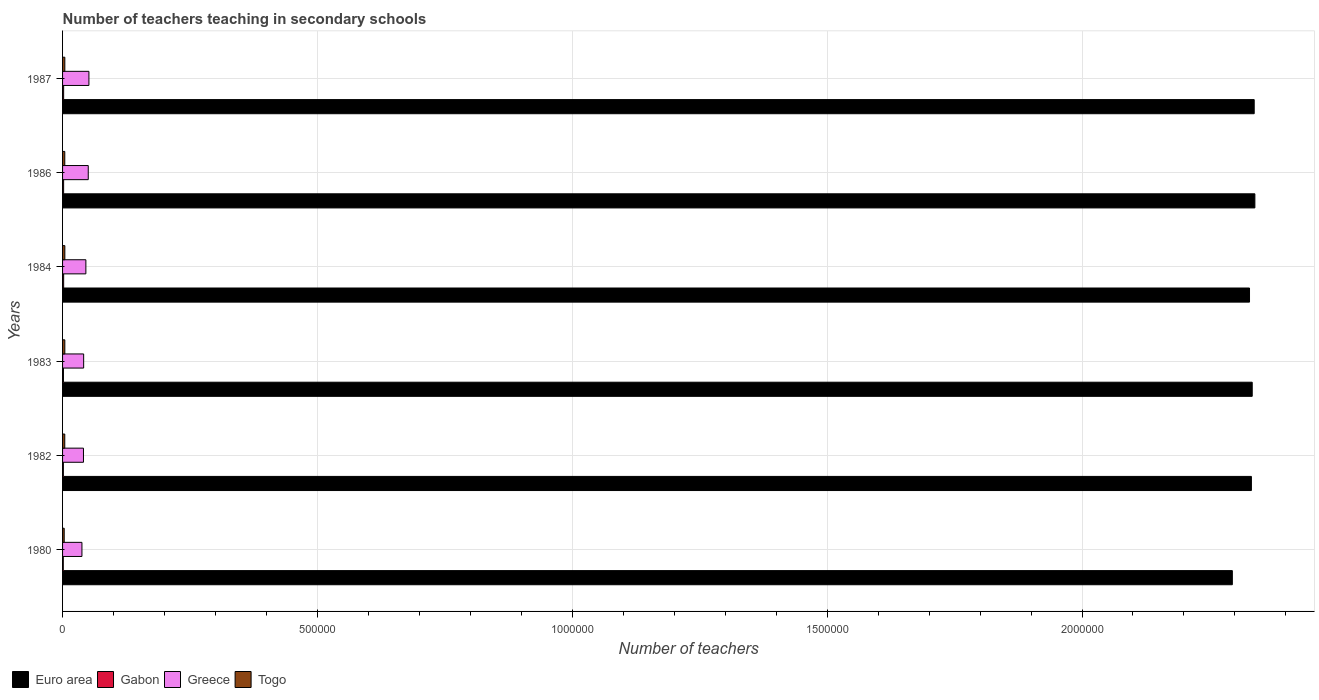How many bars are there on the 1st tick from the top?
Offer a very short reply. 4. In how many cases, is the number of bars for a given year not equal to the number of legend labels?
Your answer should be very brief. 0. What is the number of teachers teaching in secondary schools in Gabon in 1980?
Make the answer very short. 1437. Across all years, what is the maximum number of teachers teaching in secondary schools in Togo?
Offer a terse response. 4481. Across all years, what is the minimum number of teachers teaching in secondary schools in Greece?
Provide a succinct answer. 3.80e+04. In which year was the number of teachers teaching in secondary schools in Togo maximum?
Offer a terse response. 1984. What is the total number of teachers teaching in secondary schools in Gabon in the graph?
Give a very brief answer. 1.11e+04. What is the difference between the number of teachers teaching in secondary schools in Gabon in 1980 and that in 1984?
Offer a very short reply. -698. What is the difference between the number of teachers teaching in secondary schools in Euro area in 1987 and the number of teachers teaching in secondary schools in Greece in 1986?
Your response must be concise. 2.29e+06. What is the average number of teachers teaching in secondary schools in Greece per year?
Your response must be concise. 4.47e+04. In the year 1986, what is the difference between the number of teachers teaching in secondary schools in Gabon and number of teachers teaching in secondary schools in Euro area?
Keep it short and to the point. -2.34e+06. In how many years, is the number of teachers teaching in secondary schools in Gabon greater than 100000 ?
Offer a terse response. 0. What is the ratio of the number of teachers teaching in secondary schools in Gabon in 1982 to that in 1983?
Give a very brief answer. 0.91. Is the number of teachers teaching in secondary schools in Euro area in 1983 less than that in 1986?
Ensure brevity in your answer.  Yes. What is the difference between the highest and the second highest number of teachers teaching in secondary schools in Togo?
Your response must be concise. 43. What is the difference between the highest and the lowest number of teachers teaching in secondary schools in Togo?
Provide a succinct answer. 1264. What does the 1st bar from the top in 1986 represents?
Keep it short and to the point. Togo. How many years are there in the graph?
Ensure brevity in your answer.  6. Are the values on the major ticks of X-axis written in scientific E-notation?
Keep it short and to the point. No. Does the graph contain any zero values?
Provide a short and direct response. No. Where does the legend appear in the graph?
Provide a succinct answer. Bottom left. How many legend labels are there?
Your response must be concise. 4. How are the legend labels stacked?
Your answer should be very brief. Horizontal. What is the title of the graph?
Your answer should be compact. Number of teachers teaching in secondary schools. What is the label or title of the X-axis?
Offer a terse response. Number of teachers. What is the label or title of the Y-axis?
Make the answer very short. Years. What is the Number of teachers in Euro area in 1980?
Your answer should be very brief. 2.29e+06. What is the Number of teachers of Gabon in 1980?
Offer a terse response. 1437. What is the Number of teachers in Greece in 1980?
Your answer should be very brief. 3.80e+04. What is the Number of teachers of Togo in 1980?
Make the answer very short. 3217. What is the Number of teachers of Euro area in 1982?
Keep it short and to the point. 2.33e+06. What is the Number of teachers in Gabon in 1982?
Provide a short and direct response. 1583. What is the Number of teachers of Greece in 1982?
Ensure brevity in your answer.  4.10e+04. What is the Number of teachers in Togo in 1982?
Your response must be concise. 4319. What is the Number of teachers in Euro area in 1983?
Your response must be concise. 2.33e+06. What is the Number of teachers in Gabon in 1983?
Make the answer very short. 1743. What is the Number of teachers in Greece in 1983?
Make the answer very short. 4.14e+04. What is the Number of teachers of Togo in 1983?
Your answer should be compact. 4438. What is the Number of teachers of Euro area in 1984?
Provide a short and direct response. 2.33e+06. What is the Number of teachers in Gabon in 1984?
Keep it short and to the point. 2135. What is the Number of teachers of Greece in 1984?
Make the answer very short. 4.57e+04. What is the Number of teachers in Togo in 1984?
Provide a short and direct response. 4481. What is the Number of teachers in Euro area in 1986?
Make the answer very short. 2.34e+06. What is the Number of teachers in Gabon in 1986?
Ensure brevity in your answer.  2074. What is the Number of teachers in Greece in 1986?
Keep it short and to the point. 5.04e+04. What is the Number of teachers in Togo in 1986?
Your answer should be compact. 4351. What is the Number of teachers of Euro area in 1987?
Ensure brevity in your answer.  2.34e+06. What is the Number of teachers in Gabon in 1987?
Your answer should be very brief. 2120. What is the Number of teachers of Greece in 1987?
Ensure brevity in your answer.  5.17e+04. What is the Number of teachers of Togo in 1987?
Offer a very short reply. 4424. Across all years, what is the maximum Number of teachers of Euro area?
Provide a short and direct response. 2.34e+06. Across all years, what is the maximum Number of teachers of Gabon?
Keep it short and to the point. 2135. Across all years, what is the maximum Number of teachers in Greece?
Keep it short and to the point. 5.17e+04. Across all years, what is the maximum Number of teachers in Togo?
Keep it short and to the point. 4481. Across all years, what is the minimum Number of teachers of Euro area?
Ensure brevity in your answer.  2.29e+06. Across all years, what is the minimum Number of teachers of Gabon?
Make the answer very short. 1437. Across all years, what is the minimum Number of teachers in Greece?
Give a very brief answer. 3.80e+04. Across all years, what is the minimum Number of teachers of Togo?
Offer a terse response. 3217. What is the total Number of teachers in Euro area in the graph?
Offer a very short reply. 1.40e+07. What is the total Number of teachers of Gabon in the graph?
Your response must be concise. 1.11e+04. What is the total Number of teachers in Greece in the graph?
Your answer should be very brief. 2.68e+05. What is the total Number of teachers of Togo in the graph?
Your answer should be very brief. 2.52e+04. What is the difference between the Number of teachers in Euro area in 1980 and that in 1982?
Ensure brevity in your answer.  -3.74e+04. What is the difference between the Number of teachers of Gabon in 1980 and that in 1982?
Your answer should be compact. -146. What is the difference between the Number of teachers of Greece in 1980 and that in 1982?
Give a very brief answer. -3024. What is the difference between the Number of teachers in Togo in 1980 and that in 1982?
Provide a succinct answer. -1102. What is the difference between the Number of teachers in Euro area in 1980 and that in 1983?
Keep it short and to the point. -3.90e+04. What is the difference between the Number of teachers of Gabon in 1980 and that in 1983?
Your answer should be compact. -306. What is the difference between the Number of teachers of Greece in 1980 and that in 1983?
Offer a terse response. -3368. What is the difference between the Number of teachers in Togo in 1980 and that in 1983?
Your answer should be compact. -1221. What is the difference between the Number of teachers of Euro area in 1980 and that in 1984?
Provide a short and direct response. -3.37e+04. What is the difference between the Number of teachers of Gabon in 1980 and that in 1984?
Make the answer very short. -698. What is the difference between the Number of teachers in Greece in 1980 and that in 1984?
Provide a short and direct response. -7715. What is the difference between the Number of teachers in Togo in 1980 and that in 1984?
Provide a succinct answer. -1264. What is the difference between the Number of teachers in Euro area in 1980 and that in 1986?
Provide a short and direct response. -4.42e+04. What is the difference between the Number of teachers of Gabon in 1980 and that in 1986?
Give a very brief answer. -637. What is the difference between the Number of teachers in Greece in 1980 and that in 1986?
Your answer should be compact. -1.24e+04. What is the difference between the Number of teachers in Togo in 1980 and that in 1986?
Offer a terse response. -1134. What is the difference between the Number of teachers of Euro area in 1980 and that in 1987?
Offer a very short reply. -4.29e+04. What is the difference between the Number of teachers in Gabon in 1980 and that in 1987?
Provide a succinct answer. -683. What is the difference between the Number of teachers of Greece in 1980 and that in 1987?
Make the answer very short. -1.37e+04. What is the difference between the Number of teachers in Togo in 1980 and that in 1987?
Your answer should be compact. -1207. What is the difference between the Number of teachers in Euro area in 1982 and that in 1983?
Provide a short and direct response. -1573.5. What is the difference between the Number of teachers of Gabon in 1982 and that in 1983?
Ensure brevity in your answer.  -160. What is the difference between the Number of teachers of Greece in 1982 and that in 1983?
Your response must be concise. -344. What is the difference between the Number of teachers of Togo in 1982 and that in 1983?
Your answer should be compact. -119. What is the difference between the Number of teachers of Euro area in 1982 and that in 1984?
Offer a very short reply. 3733. What is the difference between the Number of teachers of Gabon in 1982 and that in 1984?
Provide a succinct answer. -552. What is the difference between the Number of teachers in Greece in 1982 and that in 1984?
Keep it short and to the point. -4691. What is the difference between the Number of teachers in Togo in 1982 and that in 1984?
Your response must be concise. -162. What is the difference between the Number of teachers in Euro area in 1982 and that in 1986?
Provide a succinct answer. -6799.75. What is the difference between the Number of teachers in Gabon in 1982 and that in 1986?
Provide a succinct answer. -491. What is the difference between the Number of teachers of Greece in 1982 and that in 1986?
Provide a succinct answer. -9365. What is the difference between the Number of teachers of Togo in 1982 and that in 1986?
Your answer should be very brief. -32. What is the difference between the Number of teachers of Euro area in 1982 and that in 1987?
Your answer should be very brief. -5475.5. What is the difference between the Number of teachers of Gabon in 1982 and that in 1987?
Your response must be concise. -537. What is the difference between the Number of teachers in Greece in 1982 and that in 1987?
Your answer should be very brief. -1.07e+04. What is the difference between the Number of teachers of Togo in 1982 and that in 1987?
Offer a very short reply. -105. What is the difference between the Number of teachers in Euro area in 1983 and that in 1984?
Provide a succinct answer. 5306.5. What is the difference between the Number of teachers in Gabon in 1983 and that in 1984?
Provide a succinct answer. -392. What is the difference between the Number of teachers in Greece in 1983 and that in 1984?
Make the answer very short. -4347. What is the difference between the Number of teachers of Togo in 1983 and that in 1984?
Your answer should be very brief. -43. What is the difference between the Number of teachers in Euro area in 1983 and that in 1986?
Give a very brief answer. -5226.25. What is the difference between the Number of teachers in Gabon in 1983 and that in 1986?
Ensure brevity in your answer.  -331. What is the difference between the Number of teachers of Greece in 1983 and that in 1986?
Offer a very short reply. -9021. What is the difference between the Number of teachers of Togo in 1983 and that in 1986?
Provide a short and direct response. 87. What is the difference between the Number of teachers in Euro area in 1983 and that in 1987?
Your answer should be compact. -3902. What is the difference between the Number of teachers of Gabon in 1983 and that in 1987?
Your answer should be compact. -377. What is the difference between the Number of teachers in Greece in 1983 and that in 1987?
Offer a very short reply. -1.03e+04. What is the difference between the Number of teachers in Euro area in 1984 and that in 1986?
Keep it short and to the point. -1.05e+04. What is the difference between the Number of teachers in Greece in 1984 and that in 1986?
Offer a very short reply. -4674. What is the difference between the Number of teachers in Togo in 1984 and that in 1986?
Give a very brief answer. 130. What is the difference between the Number of teachers of Euro area in 1984 and that in 1987?
Ensure brevity in your answer.  -9208.5. What is the difference between the Number of teachers in Gabon in 1984 and that in 1987?
Your response must be concise. 15. What is the difference between the Number of teachers of Greece in 1984 and that in 1987?
Your answer should be very brief. -5992. What is the difference between the Number of teachers of Euro area in 1986 and that in 1987?
Keep it short and to the point. 1324.25. What is the difference between the Number of teachers of Gabon in 1986 and that in 1987?
Offer a terse response. -46. What is the difference between the Number of teachers of Greece in 1986 and that in 1987?
Ensure brevity in your answer.  -1318. What is the difference between the Number of teachers of Togo in 1986 and that in 1987?
Give a very brief answer. -73. What is the difference between the Number of teachers of Euro area in 1980 and the Number of teachers of Gabon in 1982?
Give a very brief answer. 2.29e+06. What is the difference between the Number of teachers in Euro area in 1980 and the Number of teachers in Greece in 1982?
Keep it short and to the point. 2.25e+06. What is the difference between the Number of teachers of Euro area in 1980 and the Number of teachers of Togo in 1982?
Your answer should be very brief. 2.29e+06. What is the difference between the Number of teachers in Gabon in 1980 and the Number of teachers in Greece in 1982?
Your answer should be very brief. -3.96e+04. What is the difference between the Number of teachers in Gabon in 1980 and the Number of teachers in Togo in 1982?
Your response must be concise. -2882. What is the difference between the Number of teachers of Greece in 1980 and the Number of teachers of Togo in 1982?
Offer a terse response. 3.37e+04. What is the difference between the Number of teachers of Euro area in 1980 and the Number of teachers of Gabon in 1983?
Give a very brief answer. 2.29e+06. What is the difference between the Number of teachers in Euro area in 1980 and the Number of teachers in Greece in 1983?
Your answer should be compact. 2.25e+06. What is the difference between the Number of teachers in Euro area in 1980 and the Number of teachers in Togo in 1983?
Make the answer very short. 2.29e+06. What is the difference between the Number of teachers in Gabon in 1980 and the Number of teachers in Greece in 1983?
Your response must be concise. -3.99e+04. What is the difference between the Number of teachers in Gabon in 1980 and the Number of teachers in Togo in 1983?
Provide a short and direct response. -3001. What is the difference between the Number of teachers in Greece in 1980 and the Number of teachers in Togo in 1983?
Give a very brief answer. 3.36e+04. What is the difference between the Number of teachers of Euro area in 1980 and the Number of teachers of Gabon in 1984?
Provide a succinct answer. 2.29e+06. What is the difference between the Number of teachers of Euro area in 1980 and the Number of teachers of Greece in 1984?
Offer a terse response. 2.25e+06. What is the difference between the Number of teachers of Euro area in 1980 and the Number of teachers of Togo in 1984?
Make the answer very short. 2.29e+06. What is the difference between the Number of teachers in Gabon in 1980 and the Number of teachers in Greece in 1984?
Your response must be concise. -4.43e+04. What is the difference between the Number of teachers of Gabon in 1980 and the Number of teachers of Togo in 1984?
Keep it short and to the point. -3044. What is the difference between the Number of teachers in Greece in 1980 and the Number of teachers in Togo in 1984?
Make the answer very short. 3.35e+04. What is the difference between the Number of teachers in Euro area in 1980 and the Number of teachers in Gabon in 1986?
Keep it short and to the point. 2.29e+06. What is the difference between the Number of teachers in Euro area in 1980 and the Number of teachers in Greece in 1986?
Your answer should be very brief. 2.24e+06. What is the difference between the Number of teachers in Euro area in 1980 and the Number of teachers in Togo in 1986?
Offer a very short reply. 2.29e+06. What is the difference between the Number of teachers in Gabon in 1980 and the Number of teachers in Greece in 1986?
Make the answer very short. -4.90e+04. What is the difference between the Number of teachers in Gabon in 1980 and the Number of teachers in Togo in 1986?
Your answer should be very brief. -2914. What is the difference between the Number of teachers of Greece in 1980 and the Number of teachers of Togo in 1986?
Keep it short and to the point. 3.36e+04. What is the difference between the Number of teachers of Euro area in 1980 and the Number of teachers of Gabon in 1987?
Your answer should be very brief. 2.29e+06. What is the difference between the Number of teachers of Euro area in 1980 and the Number of teachers of Greece in 1987?
Ensure brevity in your answer.  2.24e+06. What is the difference between the Number of teachers of Euro area in 1980 and the Number of teachers of Togo in 1987?
Provide a short and direct response. 2.29e+06. What is the difference between the Number of teachers of Gabon in 1980 and the Number of teachers of Greece in 1987?
Provide a succinct answer. -5.03e+04. What is the difference between the Number of teachers in Gabon in 1980 and the Number of teachers in Togo in 1987?
Your answer should be very brief. -2987. What is the difference between the Number of teachers in Greece in 1980 and the Number of teachers in Togo in 1987?
Offer a terse response. 3.36e+04. What is the difference between the Number of teachers in Euro area in 1982 and the Number of teachers in Gabon in 1983?
Give a very brief answer. 2.33e+06. What is the difference between the Number of teachers of Euro area in 1982 and the Number of teachers of Greece in 1983?
Give a very brief answer. 2.29e+06. What is the difference between the Number of teachers in Euro area in 1982 and the Number of teachers in Togo in 1983?
Your response must be concise. 2.33e+06. What is the difference between the Number of teachers in Gabon in 1982 and the Number of teachers in Greece in 1983?
Ensure brevity in your answer.  -3.98e+04. What is the difference between the Number of teachers in Gabon in 1982 and the Number of teachers in Togo in 1983?
Give a very brief answer. -2855. What is the difference between the Number of teachers in Greece in 1982 and the Number of teachers in Togo in 1983?
Ensure brevity in your answer.  3.66e+04. What is the difference between the Number of teachers in Euro area in 1982 and the Number of teachers in Gabon in 1984?
Give a very brief answer. 2.33e+06. What is the difference between the Number of teachers in Euro area in 1982 and the Number of teachers in Greece in 1984?
Offer a very short reply. 2.29e+06. What is the difference between the Number of teachers in Euro area in 1982 and the Number of teachers in Togo in 1984?
Offer a very short reply. 2.33e+06. What is the difference between the Number of teachers in Gabon in 1982 and the Number of teachers in Greece in 1984?
Your answer should be very brief. -4.41e+04. What is the difference between the Number of teachers of Gabon in 1982 and the Number of teachers of Togo in 1984?
Provide a short and direct response. -2898. What is the difference between the Number of teachers of Greece in 1982 and the Number of teachers of Togo in 1984?
Your answer should be very brief. 3.65e+04. What is the difference between the Number of teachers in Euro area in 1982 and the Number of teachers in Gabon in 1986?
Your answer should be compact. 2.33e+06. What is the difference between the Number of teachers of Euro area in 1982 and the Number of teachers of Greece in 1986?
Provide a short and direct response. 2.28e+06. What is the difference between the Number of teachers of Euro area in 1982 and the Number of teachers of Togo in 1986?
Keep it short and to the point. 2.33e+06. What is the difference between the Number of teachers in Gabon in 1982 and the Number of teachers in Greece in 1986?
Ensure brevity in your answer.  -4.88e+04. What is the difference between the Number of teachers in Gabon in 1982 and the Number of teachers in Togo in 1986?
Keep it short and to the point. -2768. What is the difference between the Number of teachers in Greece in 1982 and the Number of teachers in Togo in 1986?
Offer a very short reply. 3.67e+04. What is the difference between the Number of teachers of Euro area in 1982 and the Number of teachers of Gabon in 1987?
Provide a short and direct response. 2.33e+06. What is the difference between the Number of teachers of Euro area in 1982 and the Number of teachers of Greece in 1987?
Your answer should be very brief. 2.28e+06. What is the difference between the Number of teachers in Euro area in 1982 and the Number of teachers in Togo in 1987?
Offer a very short reply. 2.33e+06. What is the difference between the Number of teachers in Gabon in 1982 and the Number of teachers in Greece in 1987?
Give a very brief answer. -5.01e+04. What is the difference between the Number of teachers in Gabon in 1982 and the Number of teachers in Togo in 1987?
Keep it short and to the point. -2841. What is the difference between the Number of teachers of Greece in 1982 and the Number of teachers of Togo in 1987?
Ensure brevity in your answer.  3.66e+04. What is the difference between the Number of teachers of Euro area in 1983 and the Number of teachers of Gabon in 1984?
Your answer should be compact. 2.33e+06. What is the difference between the Number of teachers in Euro area in 1983 and the Number of teachers in Greece in 1984?
Keep it short and to the point. 2.29e+06. What is the difference between the Number of teachers in Euro area in 1983 and the Number of teachers in Togo in 1984?
Provide a succinct answer. 2.33e+06. What is the difference between the Number of teachers in Gabon in 1983 and the Number of teachers in Greece in 1984?
Offer a terse response. -4.40e+04. What is the difference between the Number of teachers in Gabon in 1983 and the Number of teachers in Togo in 1984?
Your answer should be compact. -2738. What is the difference between the Number of teachers in Greece in 1983 and the Number of teachers in Togo in 1984?
Offer a very short reply. 3.69e+04. What is the difference between the Number of teachers of Euro area in 1983 and the Number of teachers of Gabon in 1986?
Keep it short and to the point. 2.33e+06. What is the difference between the Number of teachers of Euro area in 1983 and the Number of teachers of Greece in 1986?
Make the answer very short. 2.28e+06. What is the difference between the Number of teachers in Euro area in 1983 and the Number of teachers in Togo in 1986?
Keep it short and to the point. 2.33e+06. What is the difference between the Number of teachers of Gabon in 1983 and the Number of teachers of Greece in 1986?
Your answer should be compact. -4.86e+04. What is the difference between the Number of teachers in Gabon in 1983 and the Number of teachers in Togo in 1986?
Make the answer very short. -2608. What is the difference between the Number of teachers of Greece in 1983 and the Number of teachers of Togo in 1986?
Your answer should be very brief. 3.70e+04. What is the difference between the Number of teachers of Euro area in 1983 and the Number of teachers of Gabon in 1987?
Your answer should be compact. 2.33e+06. What is the difference between the Number of teachers of Euro area in 1983 and the Number of teachers of Greece in 1987?
Give a very brief answer. 2.28e+06. What is the difference between the Number of teachers in Euro area in 1983 and the Number of teachers in Togo in 1987?
Give a very brief answer. 2.33e+06. What is the difference between the Number of teachers in Gabon in 1983 and the Number of teachers in Greece in 1987?
Provide a short and direct response. -5.00e+04. What is the difference between the Number of teachers in Gabon in 1983 and the Number of teachers in Togo in 1987?
Provide a succinct answer. -2681. What is the difference between the Number of teachers of Greece in 1983 and the Number of teachers of Togo in 1987?
Provide a short and direct response. 3.69e+04. What is the difference between the Number of teachers in Euro area in 1984 and the Number of teachers in Gabon in 1986?
Give a very brief answer. 2.33e+06. What is the difference between the Number of teachers in Euro area in 1984 and the Number of teachers in Greece in 1986?
Keep it short and to the point. 2.28e+06. What is the difference between the Number of teachers in Euro area in 1984 and the Number of teachers in Togo in 1986?
Provide a succinct answer. 2.32e+06. What is the difference between the Number of teachers in Gabon in 1984 and the Number of teachers in Greece in 1986?
Your response must be concise. -4.83e+04. What is the difference between the Number of teachers in Gabon in 1984 and the Number of teachers in Togo in 1986?
Make the answer very short. -2216. What is the difference between the Number of teachers of Greece in 1984 and the Number of teachers of Togo in 1986?
Provide a short and direct response. 4.14e+04. What is the difference between the Number of teachers in Euro area in 1984 and the Number of teachers in Gabon in 1987?
Your response must be concise. 2.33e+06. What is the difference between the Number of teachers in Euro area in 1984 and the Number of teachers in Greece in 1987?
Provide a succinct answer. 2.28e+06. What is the difference between the Number of teachers of Euro area in 1984 and the Number of teachers of Togo in 1987?
Provide a succinct answer. 2.32e+06. What is the difference between the Number of teachers of Gabon in 1984 and the Number of teachers of Greece in 1987?
Provide a short and direct response. -4.96e+04. What is the difference between the Number of teachers in Gabon in 1984 and the Number of teachers in Togo in 1987?
Keep it short and to the point. -2289. What is the difference between the Number of teachers of Greece in 1984 and the Number of teachers of Togo in 1987?
Offer a very short reply. 4.13e+04. What is the difference between the Number of teachers in Euro area in 1986 and the Number of teachers in Gabon in 1987?
Offer a very short reply. 2.34e+06. What is the difference between the Number of teachers in Euro area in 1986 and the Number of teachers in Greece in 1987?
Your answer should be very brief. 2.29e+06. What is the difference between the Number of teachers in Euro area in 1986 and the Number of teachers in Togo in 1987?
Keep it short and to the point. 2.33e+06. What is the difference between the Number of teachers in Gabon in 1986 and the Number of teachers in Greece in 1987?
Offer a terse response. -4.96e+04. What is the difference between the Number of teachers in Gabon in 1986 and the Number of teachers in Togo in 1987?
Ensure brevity in your answer.  -2350. What is the difference between the Number of teachers of Greece in 1986 and the Number of teachers of Togo in 1987?
Offer a terse response. 4.60e+04. What is the average Number of teachers of Euro area per year?
Ensure brevity in your answer.  2.33e+06. What is the average Number of teachers of Gabon per year?
Offer a terse response. 1848.67. What is the average Number of teachers of Greece per year?
Offer a terse response. 4.47e+04. What is the average Number of teachers of Togo per year?
Provide a succinct answer. 4205. In the year 1980, what is the difference between the Number of teachers in Euro area and Number of teachers in Gabon?
Offer a terse response. 2.29e+06. In the year 1980, what is the difference between the Number of teachers in Euro area and Number of teachers in Greece?
Ensure brevity in your answer.  2.26e+06. In the year 1980, what is the difference between the Number of teachers of Euro area and Number of teachers of Togo?
Your response must be concise. 2.29e+06. In the year 1980, what is the difference between the Number of teachers of Gabon and Number of teachers of Greece?
Provide a short and direct response. -3.66e+04. In the year 1980, what is the difference between the Number of teachers of Gabon and Number of teachers of Togo?
Your answer should be compact. -1780. In the year 1980, what is the difference between the Number of teachers of Greece and Number of teachers of Togo?
Offer a very short reply. 3.48e+04. In the year 1982, what is the difference between the Number of teachers in Euro area and Number of teachers in Gabon?
Make the answer very short. 2.33e+06. In the year 1982, what is the difference between the Number of teachers in Euro area and Number of teachers in Greece?
Ensure brevity in your answer.  2.29e+06. In the year 1982, what is the difference between the Number of teachers of Euro area and Number of teachers of Togo?
Your answer should be compact. 2.33e+06. In the year 1982, what is the difference between the Number of teachers of Gabon and Number of teachers of Greece?
Provide a short and direct response. -3.94e+04. In the year 1982, what is the difference between the Number of teachers in Gabon and Number of teachers in Togo?
Your answer should be compact. -2736. In the year 1982, what is the difference between the Number of teachers of Greece and Number of teachers of Togo?
Provide a short and direct response. 3.67e+04. In the year 1983, what is the difference between the Number of teachers of Euro area and Number of teachers of Gabon?
Your answer should be compact. 2.33e+06. In the year 1983, what is the difference between the Number of teachers of Euro area and Number of teachers of Greece?
Keep it short and to the point. 2.29e+06. In the year 1983, what is the difference between the Number of teachers of Euro area and Number of teachers of Togo?
Your response must be concise. 2.33e+06. In the year 1983, what is the difference between the Number of teachers in Gabon and Number of teachers in Greece?
Make the answer very short. -3.96e+04. In the year 1983, what is the difference between the Number of teachers of Gabon and Number of teachers of Togo?
Make the answer very short. -2695. In the year 1983, what is the difference between the Number of teachers of Greece and Number of teachers of Togo?
Your answer should be compact. 3.69e+04. In the year 1984, what is the difference between the Number of teachers of Euro area and Number of teachers of Gabon?
Ensure brevity in your answer.  2.33e+06. In the year 1984, what is the difference between the Number of teachers of Euro area and Number of teachers of Greece?
Your answer should be compact. 2.28e+06. In the year 1984, what is the difference between the Number of teachers of Euro area and Number of teachers of Togo?
Your response must be concise. 2.32e+06. In the year 1984, what is the difference between the Number of teachers in Gabon and Number of teachers in Greece?
Give a very brief answer. -4.36e+04. In the year 1984, what is the difference between the Number of teachers in Gabon and Number of teachers in Togo?
Offer a terse response. -2346. In the year 1984, what is the difference between the Number of teachers in Greece and Number of teachers in Togo?
Offer a terse response. 4.12e+04. In the year 1986, what is the difference between the Number of teachers in Euro area and Number of teachers in Gabon?
Make the answer very short. 2.34e+06. In the year 1986, what is the difference between the Number of teachers in Euro area and Number of teachers in Greece?
Give a very brief answer. 2.29e+06. In the year 1986, what is the difference between the Number of teachers of Euro area and Number of teachers of Togo?
Your answer should be compact. 2.33e+06. In the year 1986, what is the difference between the Number of teachers of Gabon and Number of teachers of Greece?
Provide a succinct answer. -4.83e+04. In the year 1986, what is the difference between the Number of teachers in Gabon and Number of teachers in Togo?
Your answer should be compact. -2277. In the year 1986, what is the difference between the Number of teachers of Greece and Number of teachers of Togo?
Offer a very short reply. 4.60e+04. In the year 1987, what is the difference between the Number of teachers in Euro area and Number of teachers in Gabon?
Give a very brief answer. 2.34e+06. In the year 1987, what is the difference between the Number of teachers in Euro area and Number of teachers in Greece?
Your response must be concise. 2.29e+06. In the year 1987, what is the difference between the Number of teachers in Euro area and Number of teachers in Togo?
Provide a succinct answer. 2.33e+06. In the year 1987, what is the difference between the Number of teachers of Gabon and Number of teachers of Greece?
Provide a short and direct response. -4.96e+04. In the year 1987, what is the difference between the Number of teachers of Gabon and Number of teachers of Togo?
Give a very brief answer. -2304. In the year 1987, what is the difference between the Number of teachers of Greece and Number of teachers of Togo?
Ensure brevity in your answer.  4.73e+04. What is the ratio of the Number of teachers of Euro area in 1980 to that in 1982?
Ensure brevity in your answer.  0.98. What is the ratio of the Number of teachers in Gabon in 1980 to that in 1982?
Your answer should be compact. 0.91. What is the ratio of the Number of teachers of Greece in 1980 to that in 1982?
Your answer should be very brief. 0.93. What is the ratio of the Number of teachers of Togo in 1980 to that in 1982?
Make the answer very short. 0.74. What is the ratio of the Number of teachers in Euro area in 1980 to that in 1983?
Provide a short and direct response. 0.98. What is the ratio of the Number of teachers in Gabon in 1980 to that in 1983?
Your answer should be compact. 0.82. What is the ratio of the Number of teachers in Greece in 1980 to that in 1983?
Give a very brief answer. 0.92. What is the ratio of the Number of teachers of Togo in 1980 to that in 1983?
Keep it short and to the point. 0.72. What is the ratio of the Number of teachers in Euro area in 1980 to that in 1984?
Your answer should be compact. 0.99. What is the ratio of the Number of teachers in Gabon in 1980 to that in 1984?
Give a very brief answer. 0.67. What is the ratio of the Number of teachers in Greece in 1980 to that in 1984?
Your response must be concise. 0.83. What is the ratio of the Number of teachers in Togo in 1980 to that in 1984?
Give a very brief answer. 0.72. What is the ratio of the Number of teachers of Euro area in 1980 to that in 1986?
Provide a succinct answer. 0.98. What is the ratio of the Number of teachers in Gabon in 1980 to that in 1986?
Offer a very short reply. 0.69. What is the ratio of the Number of teachers of Greece in 1980 to that in 1986?
Your answer should be very brief. 0.75. What is the ratio of the Number of teachers in Togo in 1980 to that in 1986?
Give a very brief answer. 0.74. What is the ratio of the Number of teachers in Euro area in 1980 to that in 1987?
Your response must be concise. 0.98. What is the ratio of the Number of teachers of Gabon in 1980 to that in 1987?
Offer a terse response. 0.68. What is the ratio of the Number of teachers in Greece in 1980 to that in 1987?
Your answer should be very brief. 0.73. What is the ratio of the Number of teachers in Togo in 1980 to that in 1987?
Give a very brief answer. 0.73. What is the ratio of the Number of teachers in Euro area in 1982 to that in 1983?
Offer a very short reply. 1. What is the ratio of the Number of teachers of Gabon in 1982 to that in 1983?
Ensure brevity in your answer.  0.91. What is the ratio of the Number of teachers of Togo in 1982 to that in 1983?
Your response must be concise. 0.97. What is the ratio of the Number of teachers of Euro area in 1982 to that in 1984?
Provide a succinct answer. 1. What is the ratio of the Number of teachers of Gabon in 1982 to that in 1984?
Your answer should be very brief. 0.74. What is the ratio of the Number of teachers of Greece in 1982 to that in 1984?
Your answer should be compact. 0.9. What is the ratio of the Number of teachers of Togo in 1982 to that in 1984?
Make the answer very short. 0.96. What is the ratio of the Number of teachers in Gabon in 1982 to that in 1986?
Your answer should be very brief. 0.76. What is the ratio of the Number of teachers in Greece in 1982 to that in 1986?
Your answer should be very brief. 0.81. What is the ratio of the Number of teachers in Togo in 1982 to that in 1986?
Make the answer very short. 0.99. What is the ratio of the Number of teachers in Euro area in 1982 to that in 1987?
Keep it short and to the point. 1. What is the ratio of the Number of teachers in Gabon in 1982 to that in 1987?
Your answer should be compact. 0.75. What is the ratio of the Number of teachers in Greece in 1982 to that in 1987?
Keep it short and to the point. 0.79. What is the ratio of the Number of teachers of Togo in 1982 to that in 1987?
Your answer should be very brief. 0.98. What is the ratio of the Number of teachers of Euro area in 1983 to that in 1984?
Offer a terse response. 1. What is the ratio of the Number of teachers in Gabon in 1983 to that in 1984?
Your answer should be compact. 0.82. What is the ratio of the Number of teachers of Greece in 1983 to that in 1984?
Your answer should be very brief. 0.9. What is the ratio of the Number of teachers in Euro area in 1983 to that in 1986?
Your answer should be compact. 1. What is the ratio of the Number of teachers of Gabon in 1983 to that in 1986?
Make the answer very short. 0.84. What is the ratio of the Number of teachers in Greece in 1983 to that in 1986?
Make the answer very short. 0.82. What is the ratio of the Number of teachers of Euro area in 1983 to that in 1987?
Offer a very short reply. 1. What is the ratio of the Number of teachers of Gabon in 1983 to that in 1987?
Provide a short and direct response. 0.82. What is the ratio of the Number of teachers of Togo in 1983 to that in 1987?
Offer a very short reply. 1. What is the ratio of the Number of teachers of Gabon in 1984 to that in 1986?
Ensure brevity in your answer.  1.03. What is the ratio of the Number of teachers in Greece in 1984 to that in 1986?
Your answer should be compact. 0.91. What is the ratio of the Number of teachers in Togo in 1984 to that in 1986?
Ensure brevity in your answer.  1.03. What is the ratio of the Number of teachers of Euro area in 1984 to that in 1987?
Your answer should be compact. 1. What is the ratio of the Number of teachers in Gabon in 1984 to that in 1987?
Make the answer very short. 1.01. What is the ratio of the Number of teachers in Greece in 1984 to that in 1987?
Your response must be concise. 0.88. What is the ratio of the Number of teachers of Togo in 1984 to that in 1987?
Make the answer very short. 1.01. What is the ratio of the Number of teachers of Gabon in 1986 to that in 1987?
Keep it short and to the point. 0.98. What is the ratio of the Number of teachers in Greece in 1986 to that in 1987?
Your answer should be very brief. 0.97. What is the ratio of the Number of teachers in Togo in 1986 to that in 1987?
Offer a very short reply. 0.98. What is the difference between the highest and the second highest Number of teachers of Euro area?
Your response must be concise. 1324.25. What is the difference between the highest and the second highest Number of teachers of Gabon?
Ensure brevity in your answer.  15. What is the difference between the highest and the second highest Number of teachers in Greece?
Your answer should be very brief. 1318. What is the difference between the highest and the second highest Number of teachers of Togo?
Provide a short and direct response. 43. What is the difference between the highest and the lowest Number of teachers of Euro area?
Give a very brief answer. 4.42e+04. What is the difference between the highest and the lowest Number of teachers of Gabon?
Ensure brevity in your answer.  698. What is the difference between the highest and the lowest Number of teachers of Greece?
Offer a very short reply. 1.37e+04. What is the difference between the highest and the lowest Number of teachers of Togo?
Provide a short and direct response. 1264. 